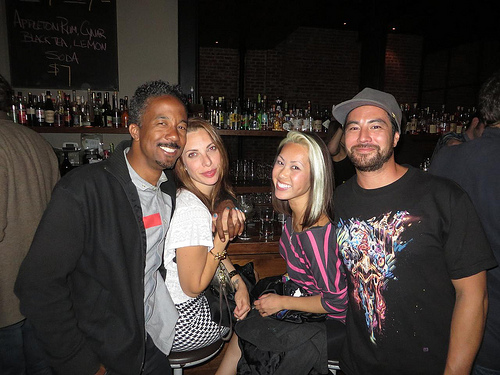<image>
Is the man behind the mujer? Yes. From this viewpoint, the man is positioned behind the mujer, with the mujer partially or fully occluding the man. 